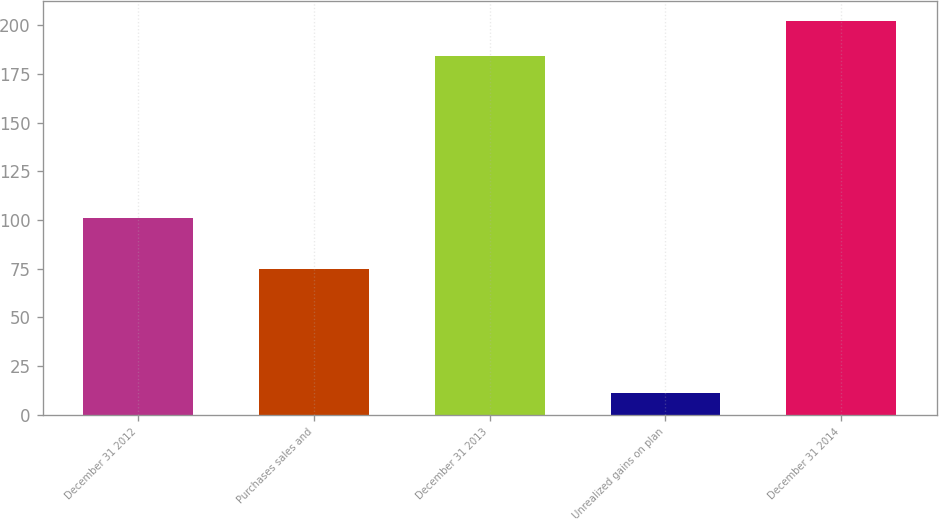Convert chart. <chart><loc_0><loc_0><loc_500><loc_500><bar_chart><fcel>December 31 2012<fcel>Purchases sales and<fcel>December 31 2013<fcel>Unrealized gains on plan<fcel>December 31 2014<nl><fcel>101<fcel>75<fcel>184<fcel>11<fcel>202.4<nl></chart> 